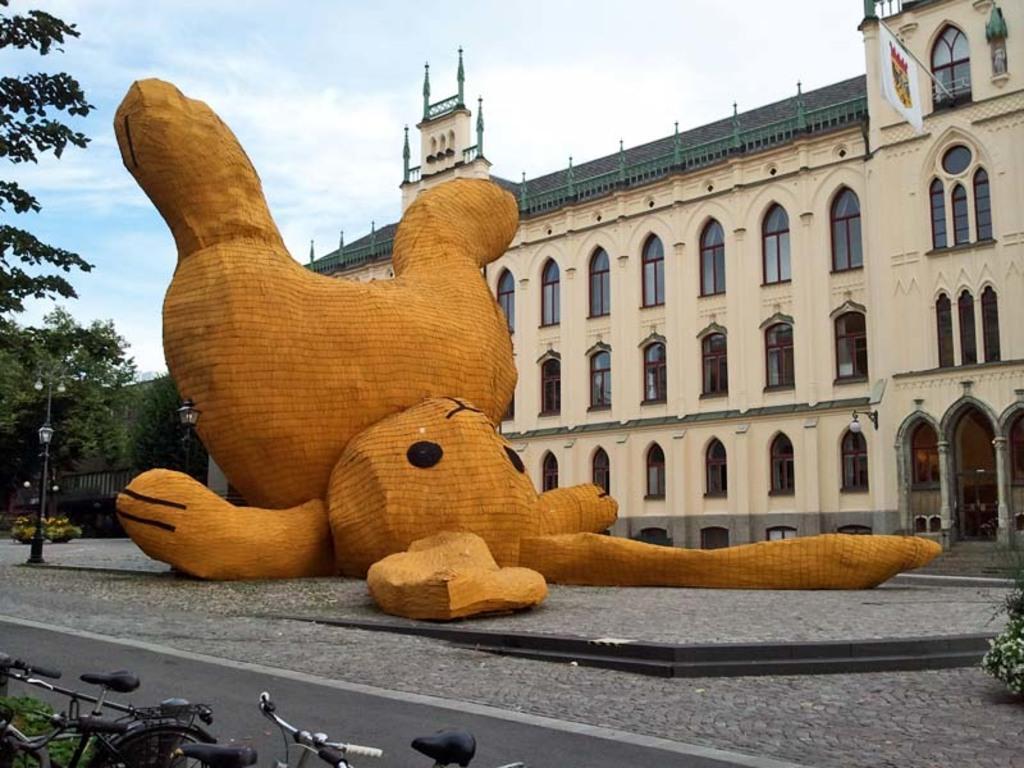In one or two sentences, can you explain what this image depicts? In this image I can see a building, in front of the building I can see a sculpture and trees and bicycles and at the top I can see the sky, on the building I can see the flag. 